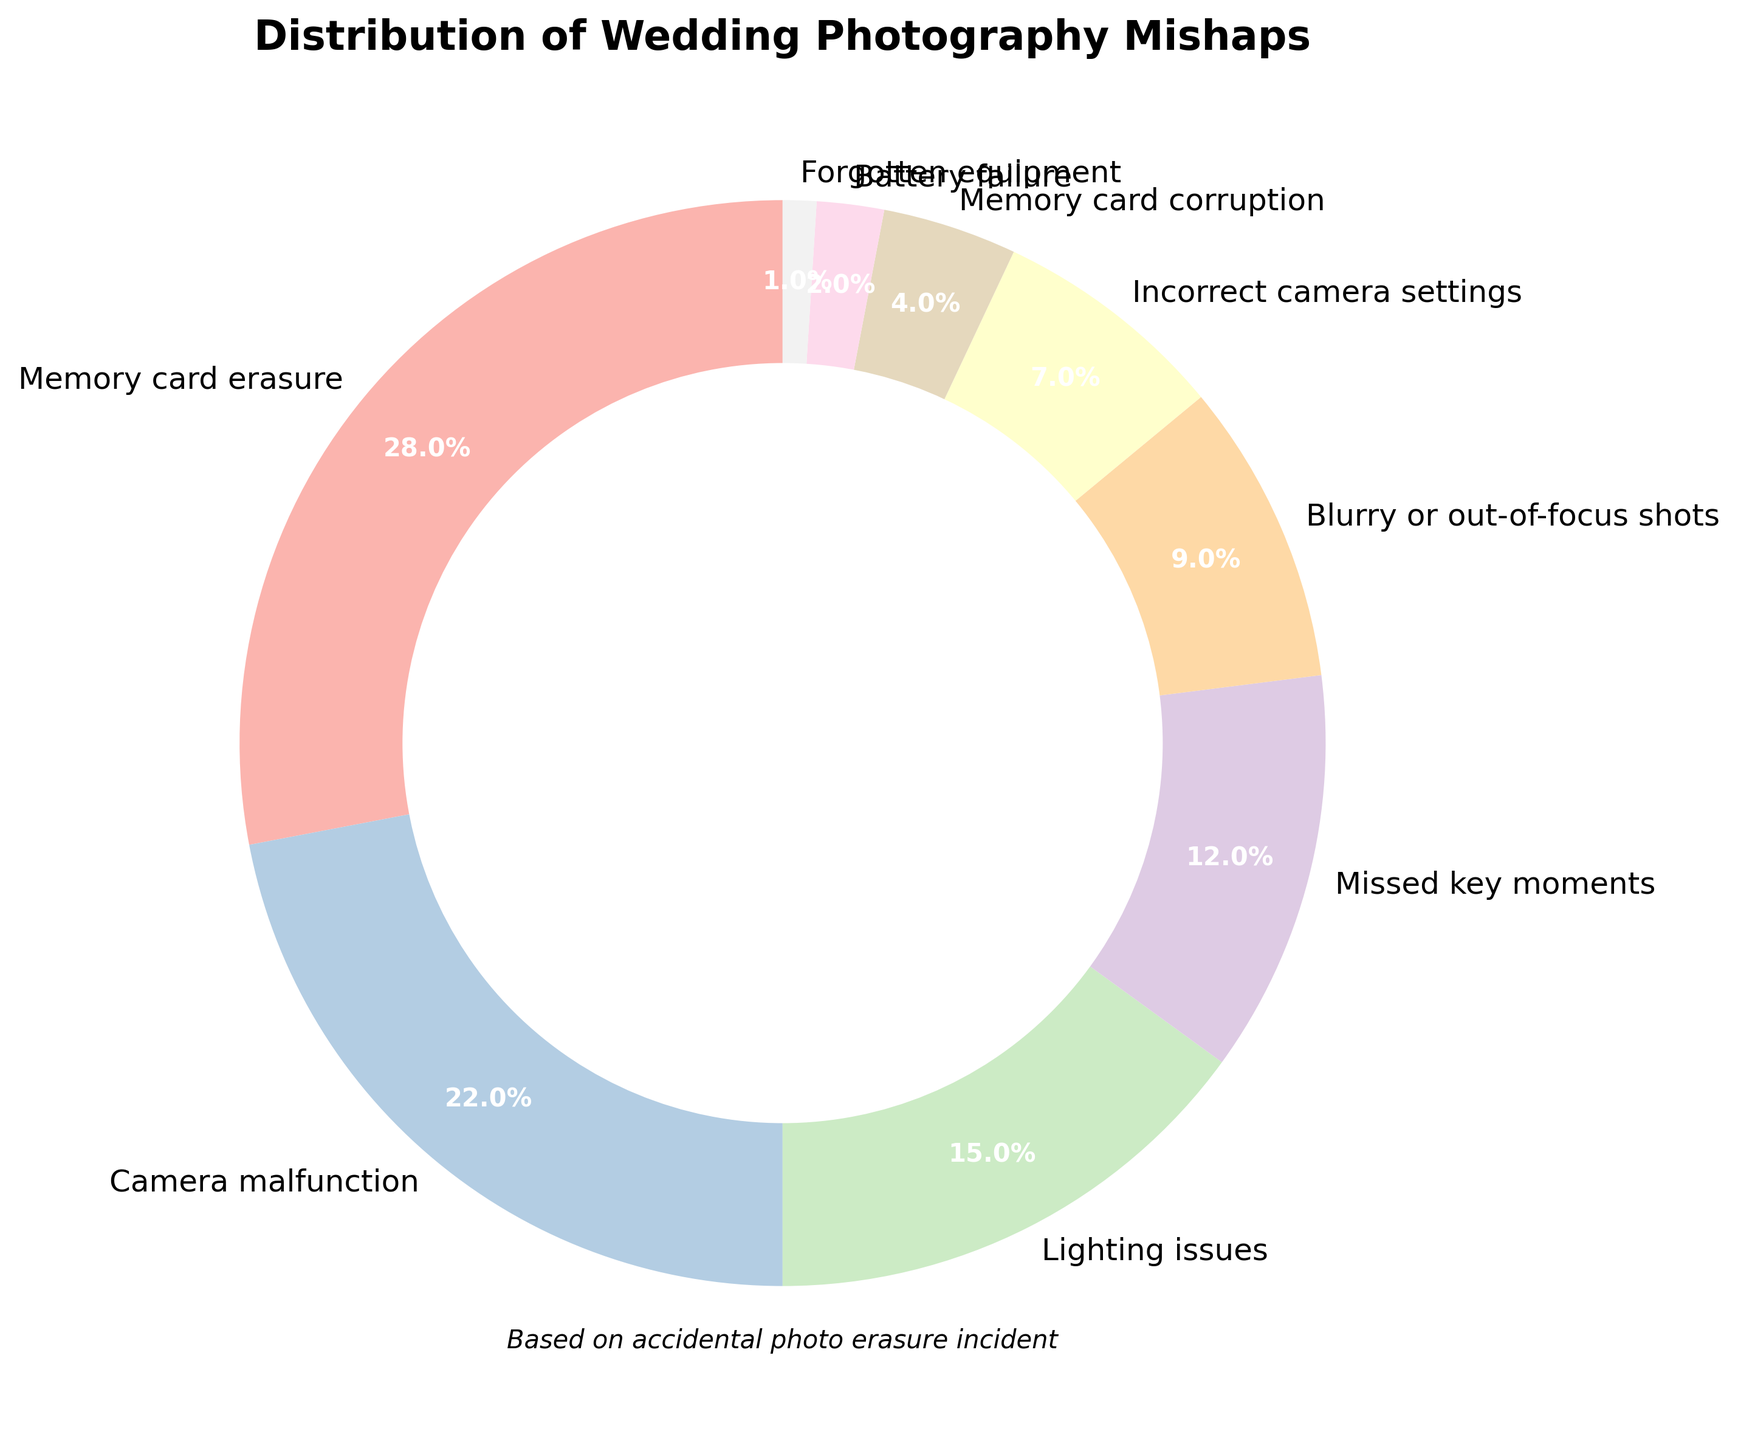What's the percentage of Memory card erasure mishaps? The pie chart shows that Memory card erasure mishaps account for 28% of the total mishaps, as indicated by the label directly on the pie chart.
Answer: 28% Which mishap category has the lowest percentage? According to the pie chart, Forgotten equipment has the lowest percentage of mishaps, coming in at just 1%. This can be identified by locating the smallest wedge in the chart.
Answer: Forgotten equipment How does the percentage of Camera malfunction compare to Lighting issues? The percentage of Camera malfunction is 22%, and the percentage of Lighting issues is 15%. Therefore, Camera malfunction is greater than Lighting issues by a margin of 7%.
Answer: Camera malfunction is 7% greater What are the combined percentages of Blurry or out-of-focus shots and Incorrect camera settings? Blurry or out-of-focus shots account for 9% and Incorrect camera settings account for 7%. By adding these two percentages together (9% + 7%), we get a combined percentage of 16%.
Answer: 16% Which mishap type holds the second highest percentage of incidents? After Memory card erasure, which has the highest percentage at 28%, the second highest is Camera malfunction at 22%. This can be determined by comparing the percentages labeled on the chart.
Answer: Camera malfunction What is the total percentage of the three least frequent mishap types? The three least frequent mishap types are Memory card corruption (4%), Battery failure (2%), and Forgotten equipment (1%). Adding these together (4% + 2% + 1%) gives us a total of 7%.
Answer: 7% By how much does Lighting issues exceed Missed key moments? Lighting issues are at 15% while Missed key moments are at 12%. The difference between them is calculated as 15% - 12%, which equals 3%.
Answer: 3% What proportion of the total mishaps are caused by issues related to the camera (including Camera malfunction and Incorrect camera settings)? Camera malfunction and Incorrect camera settings account for 22% and 7% respectively. Adding these together (22% + 7%) results in 29% of the total mishaps.
Answer: 29% Out of the total mishaps, how many percentage points higher is the Memory card erasure compared to Blurry or out-of-focus shots? Memory card erasure is 28% and Blurry or out-of-focus shots are 9%. The difference between them is 28% - 9%, which is 19%.
Answer: 19% Which mishap type is visually represented with the largest sector on the pie chart? The largest sector on the pie chart represents Memory card erasure, as it has the highest percentage of 28%.
Answer: Memory card erasure 